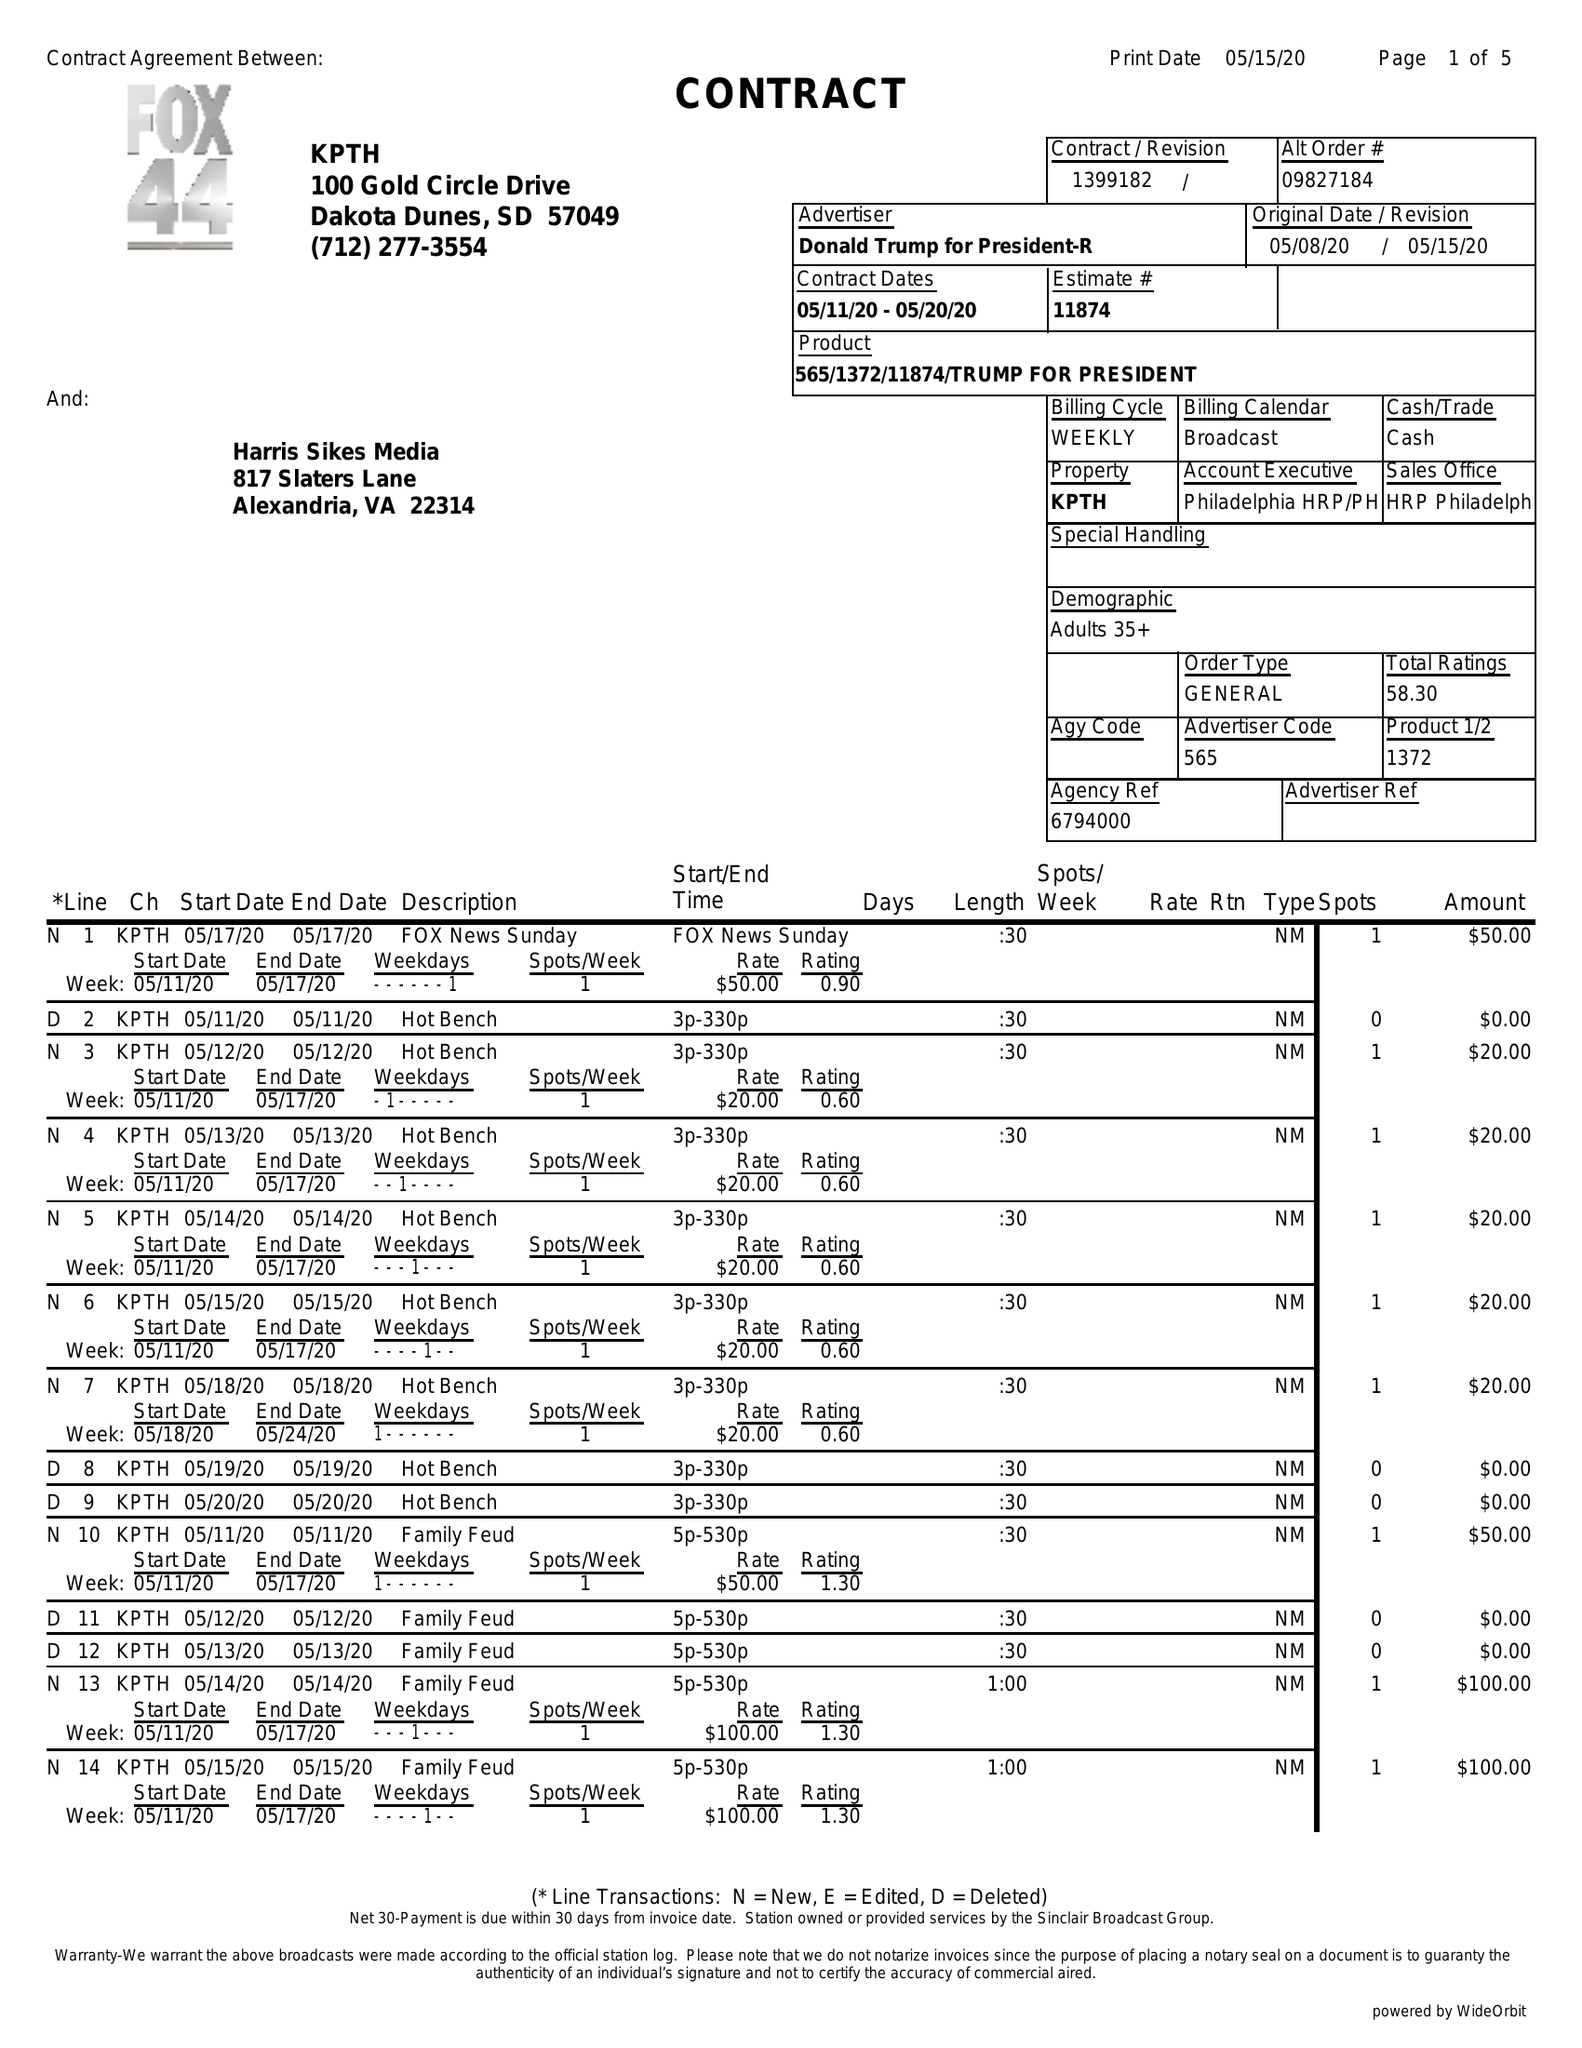What is the value for the flight_to?
Answer the question using a single word or phrase. 05/20/20 